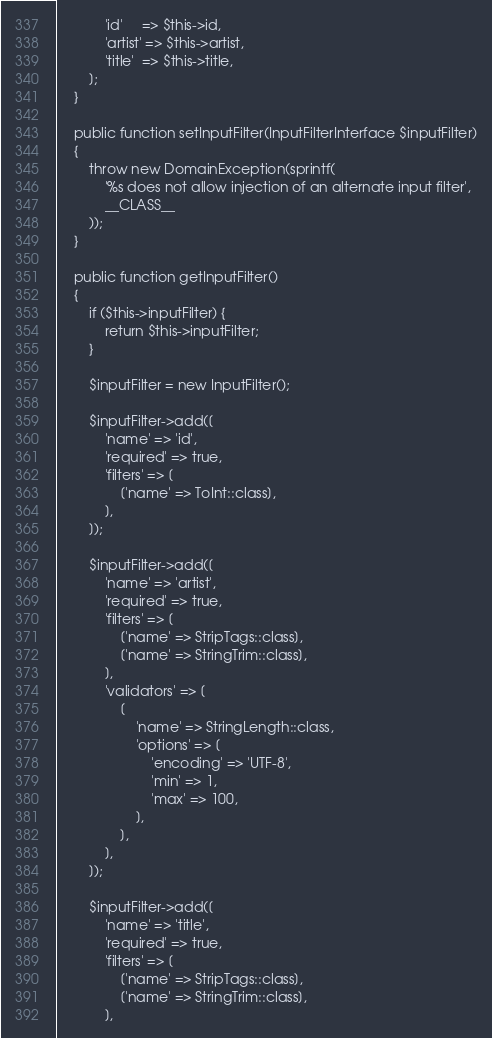Convert code to text. <code><loc_0><loc_0><loc_500><loc_500><_PHP_>            'id'     => $this->id,
            'artist' => $this->artist,
            'title'  => $this->title,
        ];
    }
    
    public function setInputFilter(InputFilterInterface $inputFilter)
    {
        throw new DomainException(sprintf(
            '%s does not allow injection of an alternate input filter',
            __CLASS__
        ));
    }

    public function getInputFilter()
    {
        if ($this->inputFilter) {
            return $this->inputFilter;
        }

        $inputFilter = new InputFilter();

        $inputFilter->add([
            'name' => 'id',
            'required' => true,
            'filters' => [
                ['name' => ToInt::class],
            ],
        ]);

        $inputFilter->add([
            'name' => 'artist',
            'required' => true,
            'filters' => [
                ['name' => StripTags::class],
                ['name' => StringTrim::class],
            ],
            'validators' => [
                [
                    'name' => StringLength::class,
                    'options' => [
                        'encoding' => 'UTF-8',
                        'min' => 1,
                        'max' => 100,
                    ],
                ],
            ],
        ]);

        $inputFilter->add([
            'name' => 'title',
            'required' => true,
            'filters' => [
                ['name' => StripTags::class],
                ['name' => StringTrim::class],
            ],</code> 